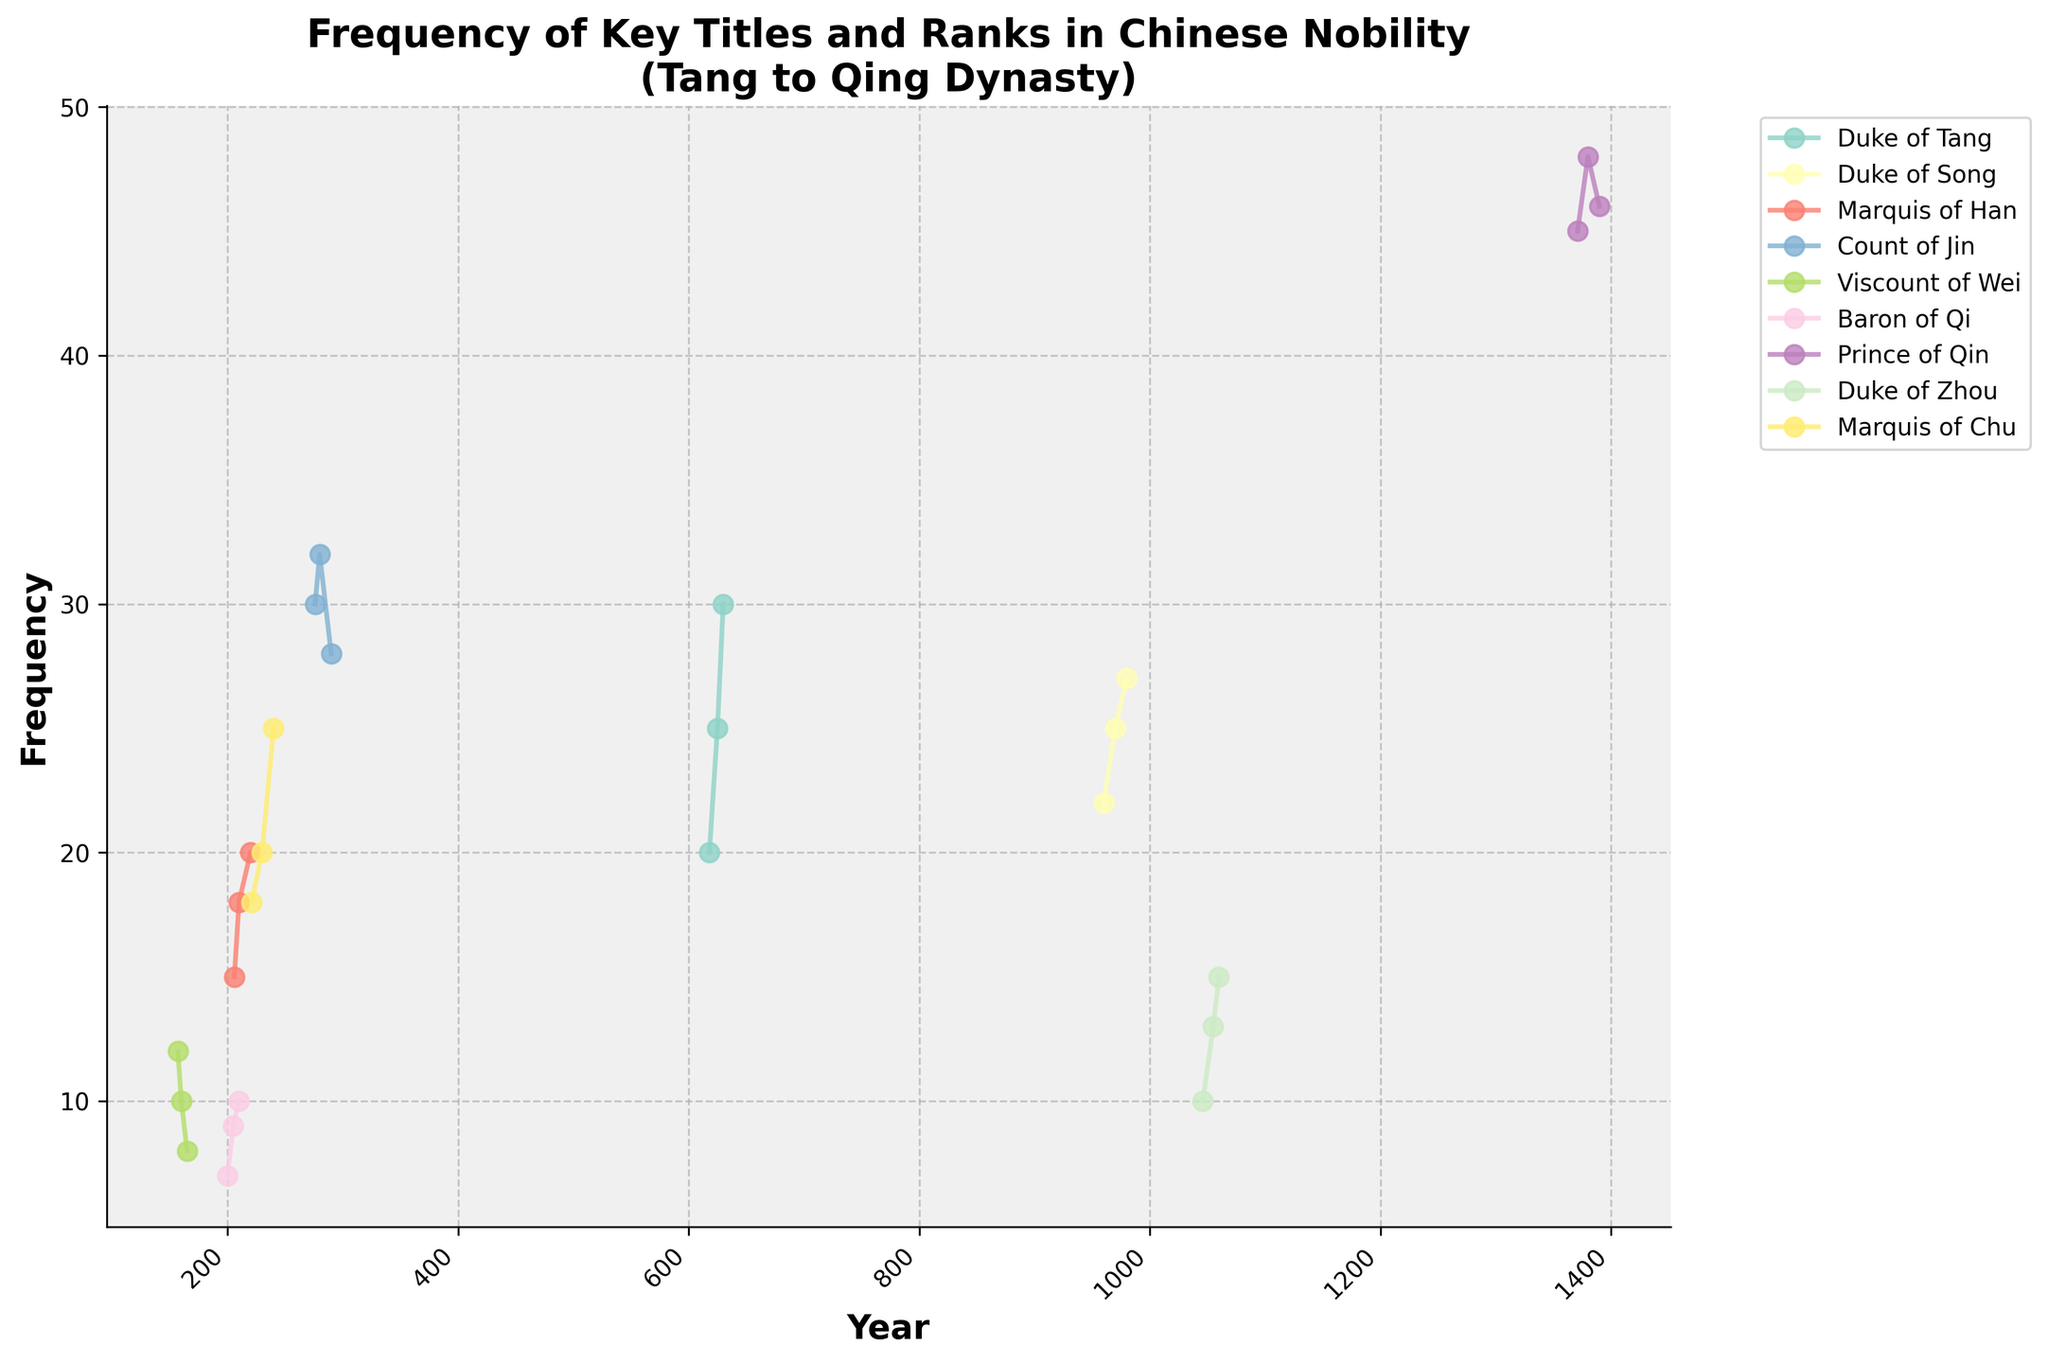What is the frequency of the 'Duke of Tang' title in the year 630? The title 'Duke of Tang' corresponds to the year 630 in the plot. Observing the vertical position of the data point for this year indicates the frequency.
Answer: 30 Which title has the highest frequency in the plot, and what is that frequency? Observing the highest point of all the lines in the plot, the 'Prince of Qin' title in the year 1380 marks the highest frequency.
Answer: Prince of Qin, 48 How does the frequency of the 'Baron of Qi' title change from the year 200 to 210? Evaluating the start and end frequencies for the 'Baron of Qi' title between the years 200 and 210, the frequency changes from 7 to 10. The frequency increases by 3.
Answer: Increases by 3 Compare the frequency of the 'Marquis of Han' and 'Marquis of Chu' titles in the year 220. Which is higher and by how much? In the year 220, the 'Marquis of Han' frequency is at 20, while the 'Marquis of Chu' shows 25, making the latter higher by 5.
Answer: Marquis of Chu, by 5 What was the average frequency of the 'Duke of Zhou' title from 1046 to 1060? Considering the years 1046, 1055, and 1060, the frequencies are 10, 13, and 15, respectively. The sum is 38, and the average is 38 divided by 3, giving approximately 12.67.
Answer: 12.67 How many data points are plotted for the 'Duke of Song' title? Observing the plot, the 'Duke of Song' title marks data points at 960, 970, and 980. Counting these points results in three.
Answer: 3 Which title shows a constant frequency across its plotted years? Observing all plotted data points, the 'Count of Jin' shows a slight fluctuation, but 'Viscount of Wei' constantly decreases, so none of the titles exhibit a constant frequency without any fluctuation.
Answer: None During which dynasty periods do we observe the titles 'Duke of Tang' and 'Duke of Song' in the plot, and what are their respective frequency trends? The 'Duke of Tang' is during the Tang dynasty (618-630) showing an increasing trend, and 'Duke of Song' during the Song dynasty (960-980) also shows an increasing trend, signifying growing usage.
Answer: Tang (increasing), Song (increasing) What is the total increase in frequency of the 'Marquis of Chu' title from 221 to 240? For the 'Marquis of Chu', the frequency at 221 is 18 and at 240 is 25. The increase from 18 to 25 results in a total increase of 7.
Answer: 7 